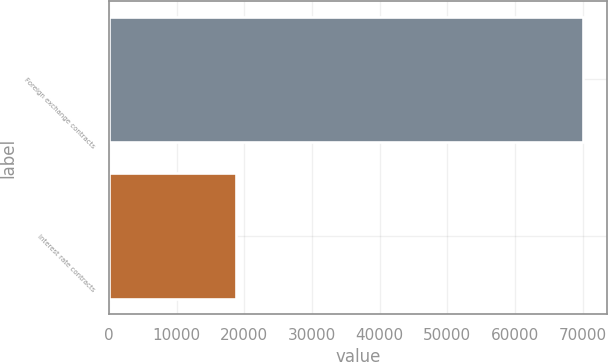Convert chart. <chart><loc_0><loc_0><loc_500><loc_500><bar_chart><fcel>Foreign exchange contracts<fcel>Interest rate contracts<nl><fcel>70054<fcel>18750<nl></chart> 